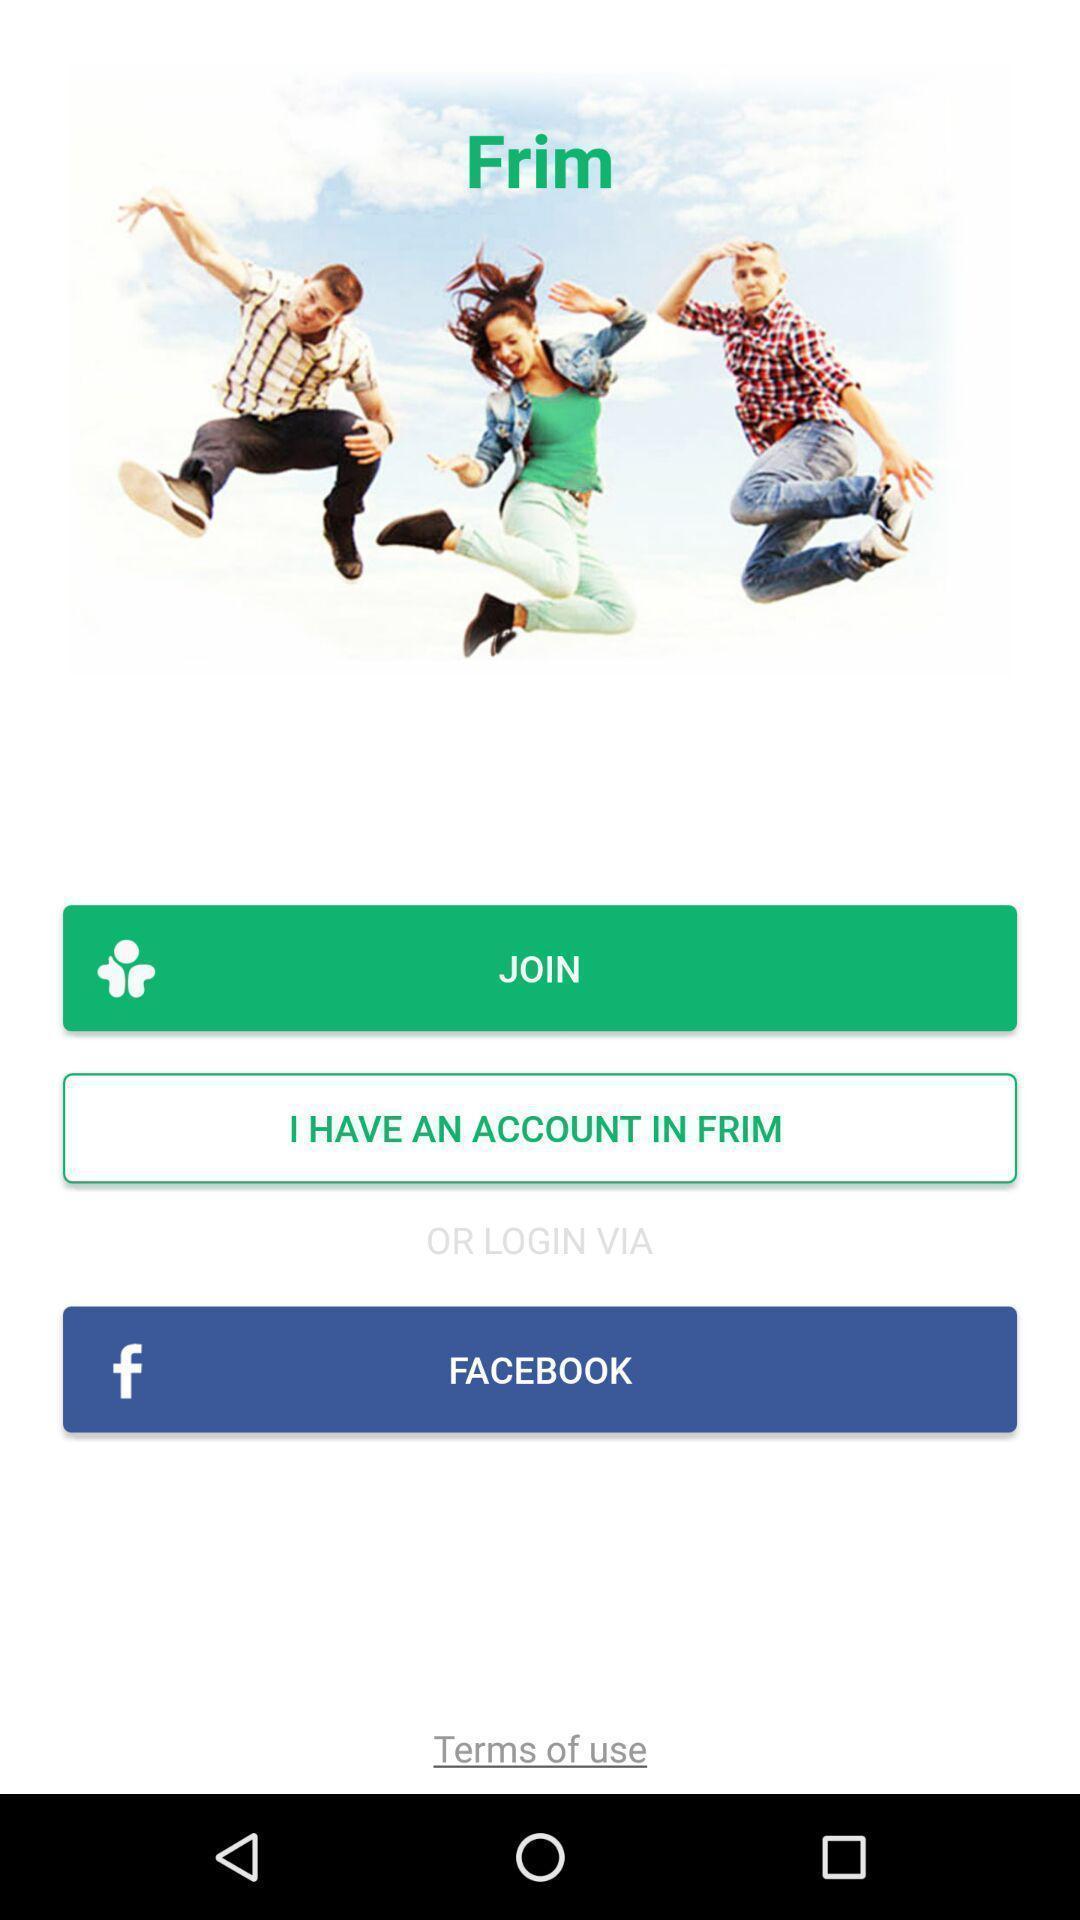Describe this image in words. Welcome to the login page. 